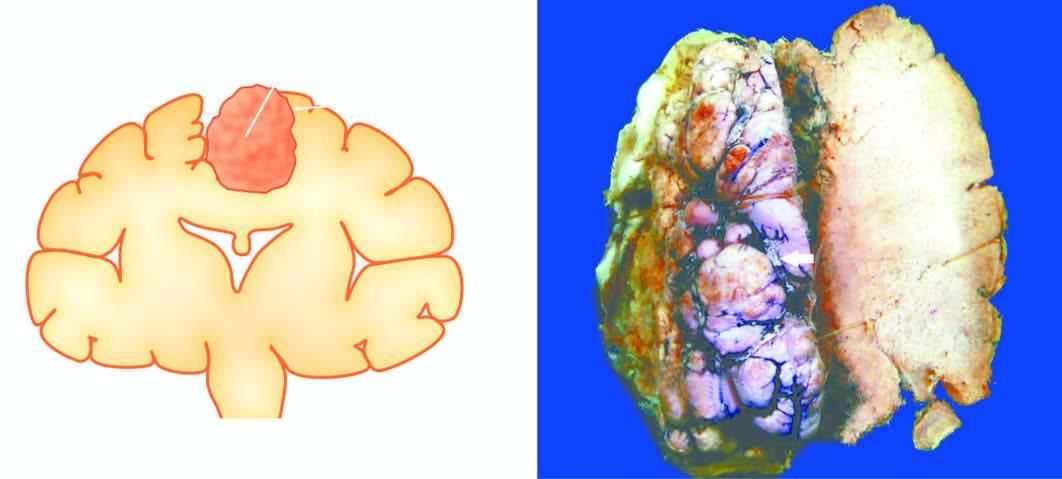s the tumour firm and fibrous?
Answer the question using a single word or phrase. No 